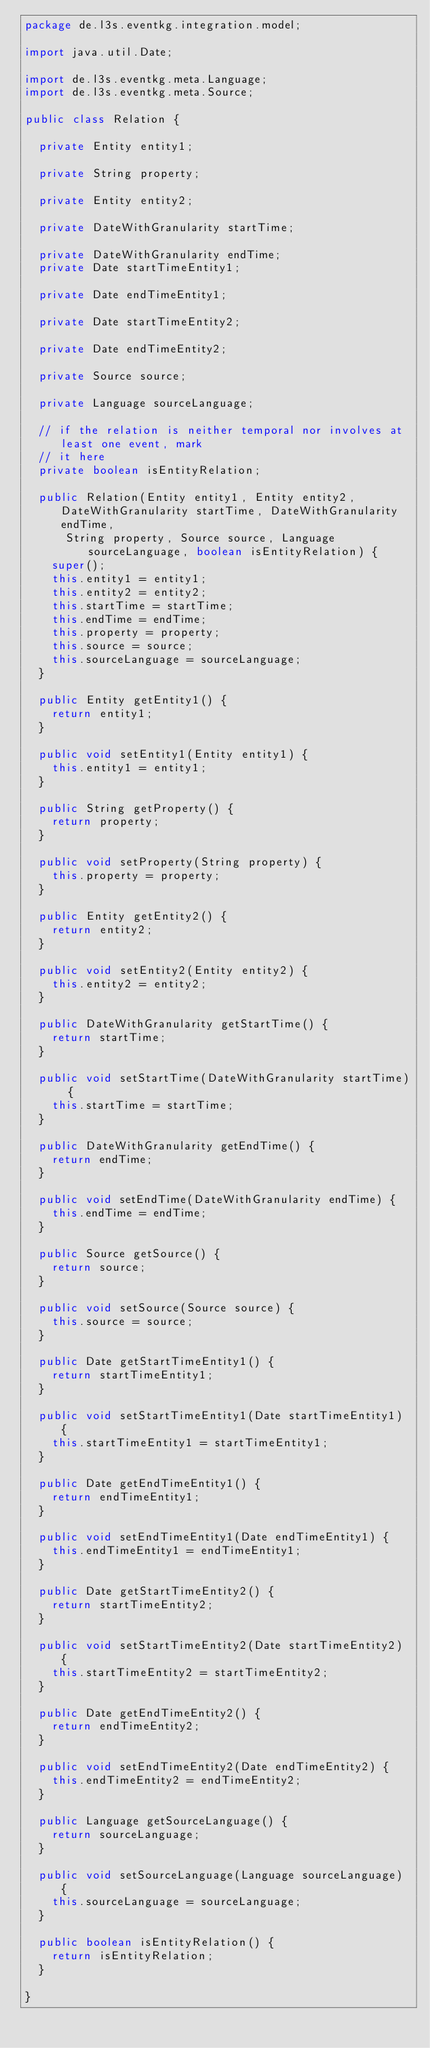Convert code to text. <code><loc_0><loc_0><loc_500><loc_500><_Java_>package de.l3s.eventkg.integration.model;

import java.util.Date;

import de.l3s.eventkg.meta.Language;
import de.l3s.eventkg.meta.Source;

public class Relation {

	private Entity entity1;

	private String property;

	private Entity entity2;

	private DateWithGranularity startTime;

	private DateWithGranularity endTime;
	private Date startTimeEntity1;

	private Date endTimeEntity1;

	private Date startTimeEntity2;

	private Date endTimeEntity2;

	private Source source;

	private Language sourceLanguage;

	// if the relation is neither temporal nor involves at least one event, mark
	// it here
	private boolean isEntityRelation;

	public Relation(Entity entity1, Entity entity2, DateWithGranularity startTime, DateWithGranularity endTime,
			String property, Source source, Language sourceLanguage, boolean isEntityRelation) {
		super();
		this.entity1 = entity1;
		this.entity2 = entity2;
		this.startTime = startTime;
		this.endTime = endTime;
		this.property = property;
		this.source = source;
		this.sourceLanguage = sourceLanguage;
	}

	public Entity getEntity1() {
		return entity1;
	}

	public void setEntity1(Entity entity1) {
		this.entity1 = entity1;
	}

	public String getProperty() {
		return property;
	}

	public void setProperty(String property) {
		this.property = property;
	}

	public Entity getEntity2() {
		return entity2;
	}

	public void setEntity2(Entity entity2) {
		this.entity2 = entity2;
	}

	public DateWithGranularity getStartTime() {
		return startTime;
	}

	public void setStartTime(DateWithGranularity startTime) {
		this.startTime = startTime;
	}

	public DateWithGranularity getEndTime() {
		return endTime;
	}

	public void setEndTime(DateWithGranularity endTime) {
		this.endTime = endTime;
	}

	public Source getSource() {
		return source;
	}

	public void setSource(Source source) {
		this.source = source;
	}

	public Date getStartTimeEntity1() {
		return startTimeEntity1;
	}

	public void setStartTimeEntity1(Date startTimeEntity1) {
		this.startTimeEntity1 = startTimeEntity1;
	}

	public Date getEndTimeEntity1() {
		return endTimeEntity1;
	}

	public void setEndTimeEntity1(Date endTimeEntity1) {
		this.endTimeEntity1 = endTimeEntity1;
	}

	public Date getStartTimeEntity2() {
		return startTimeEntity2;
	}

	public void setStartTimeEntity2(Date startTimeEntity2) {
		this.startTimeEntity2 = startTimeEntity2;
	}

	public Date getEndTimeEntity2() {
		return endTimeEntity2;
	}

	public void setEndTimeEntity2(Date endTimeEntity2) {
		this.endTimeEntity2 = endTimeEntity2;
	}

	public Language getSourceLanguage() {
		return sourceLanguage;
	}

	public void setSourceLanguage(Language sourceLanguage) {
		this.sourceLanguage = sourceLanguage;
	}

	public boolean isEntityRelation() {
		return isEntityRelation;
	}

}
</code> 